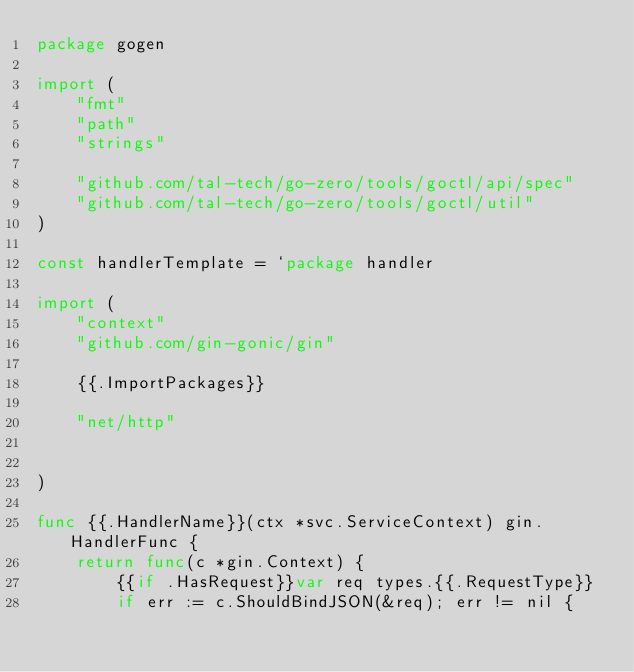Convert code to text. <code><loc_0><loc_0><loc_500><loc_500><_Go_>package gogen

import (
	"fmt"
	"path"
	"strings"

	"github.com/tal-tech/go-zero/tools/goctl/api/spec"
	"github.com/tal-tech/go-zero/tools/goctl/util"
)

const handlerTemplate = `package handler

import (
	"context"
	"github.com/gin-gonic/gin"

	{{.ImportPackages}}

	"net/http"

	
)

func {{.HandlerName}}(ctx *svc.ServiceContext) gin.HandlerFunc {
	return func(c *gin.Context) {
		{{if .HasRequest}}var req types.{{.RequestType}}
		if err := c.ShouldBindJSON(&req); err != nil {</code> 